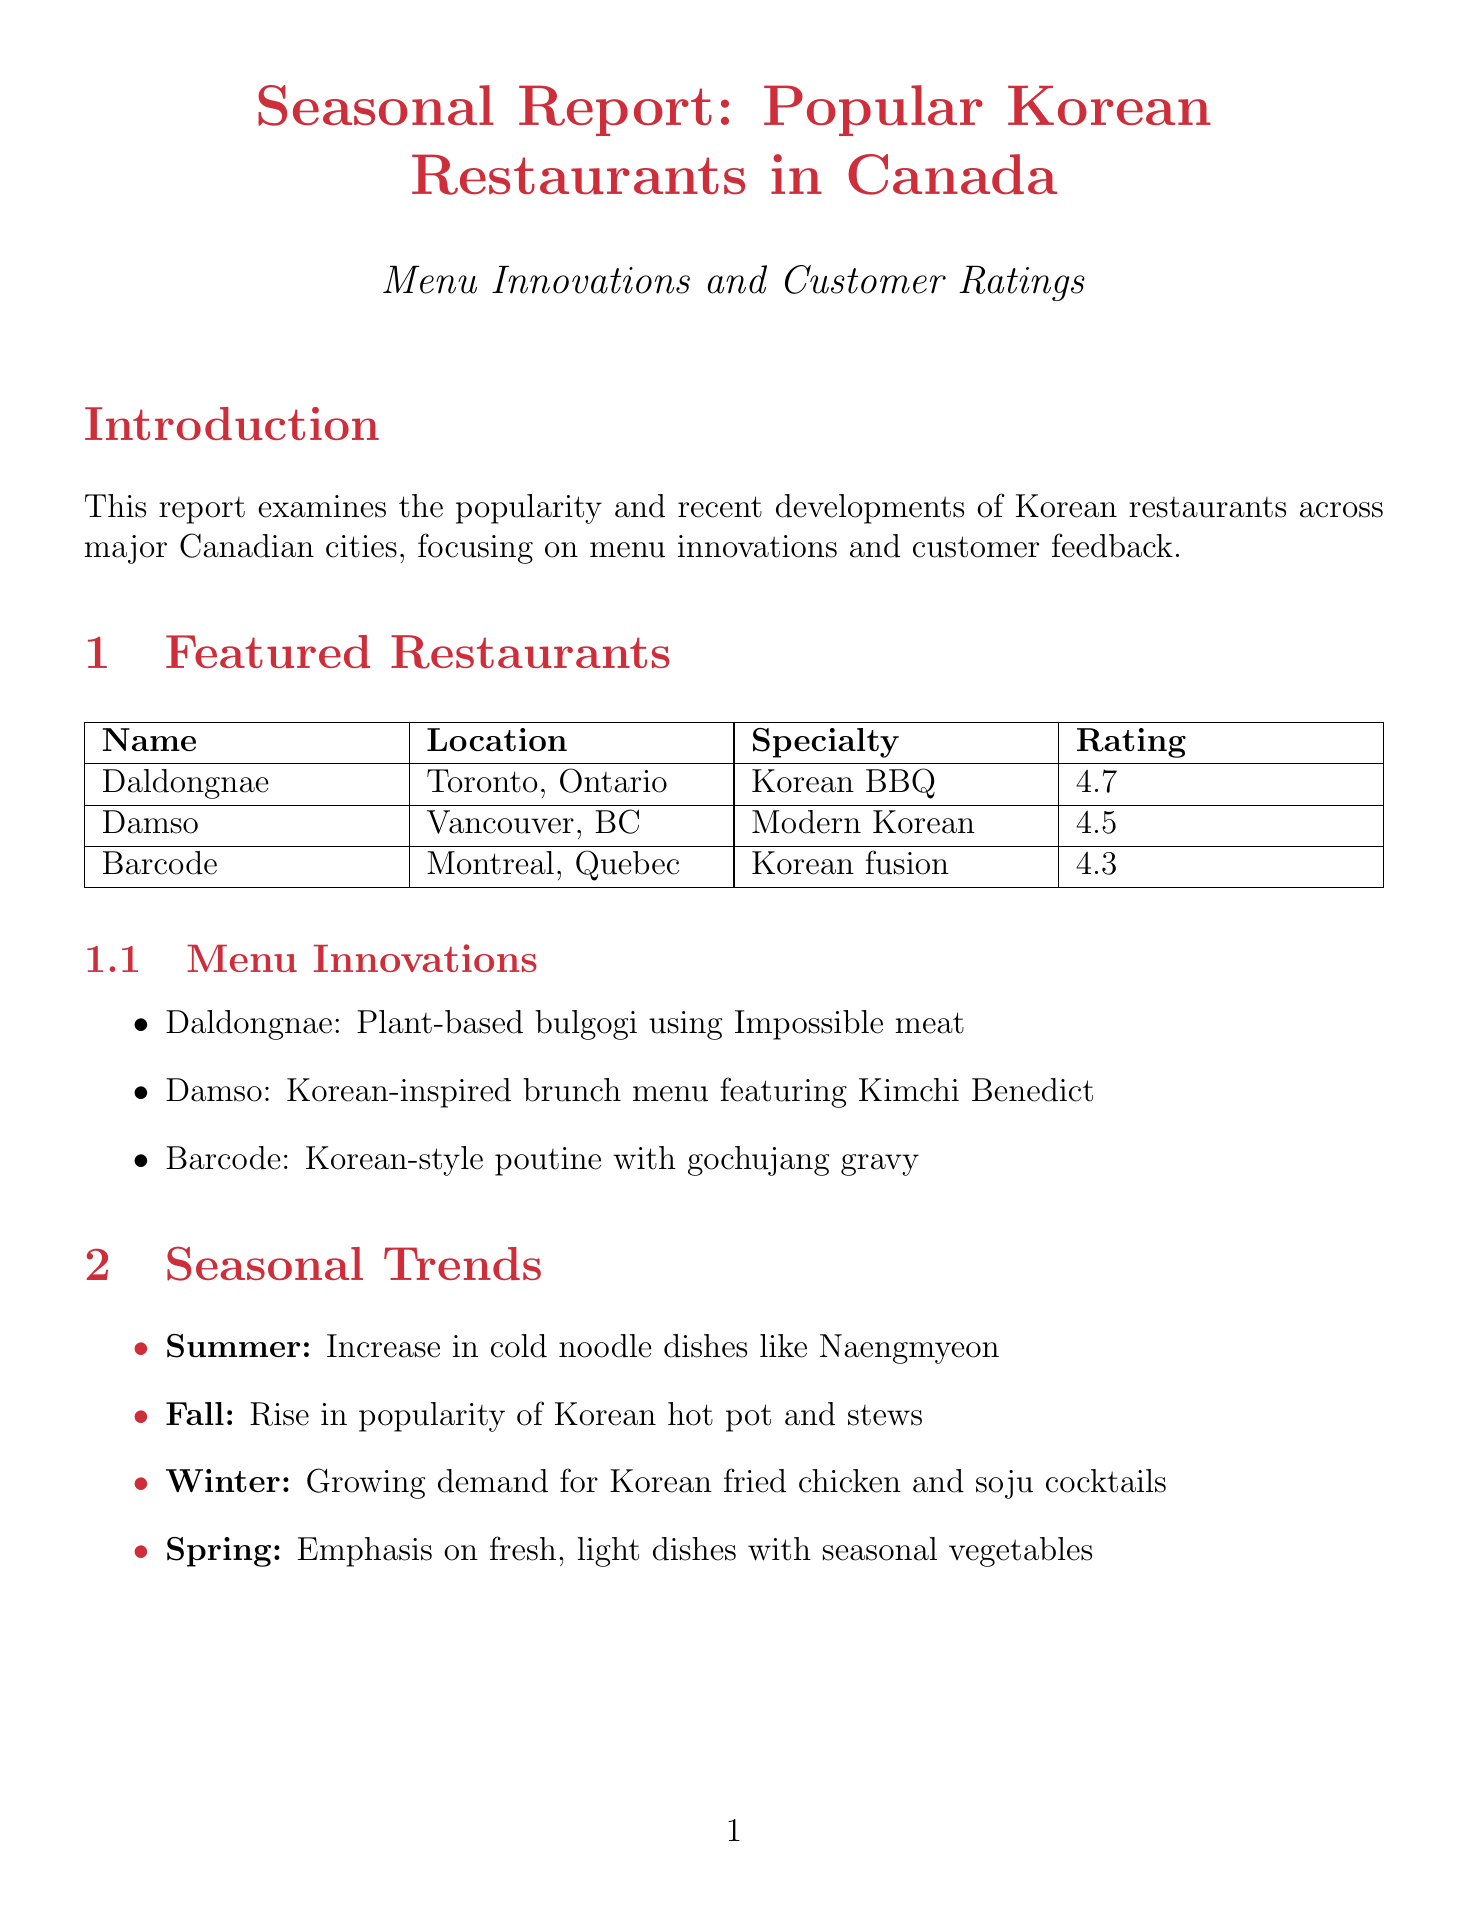What is the title of the report? The title of the report is clearly mentioned at the beginning as "Seasonal Report: Popular Korean Restaurants in Canada - Menu Innovations and Customer Ratings."
Answer: Seasonal Report: Popular Korean Restaurants in Canada - Menu Innovations and Customer Ratings What is the customer rating of Daldongnae? The customer rating of Daldongnae is specified as 4.7.
Answer: 4.7 Which dish is popular at Damso? The report states that the popular dish at Damso is "Kimchi Fried Rice."
Answer: Kimchi Fried Rice What seasonal trend is noted for summer? The seasonal trend for summer is that there is an increase in cold noodle dishes like Naengmyeon.
Answer: Increase in cold noodle dishes like Naengmyeon What is the emphasis on in the spring seasonal trend? The spring seasonal trend emphasizes fresh, light dishes incorporating seasonal vegetables.
Answer: Fresh, light dishes incorporating seasonal vegetables Which region is noted for emphasizing seafood dishes? The report highlights that the West Coast places greater emphasis on seafood dishes and vegetarian options.
Answer: West Coast What is one of the emerging trends mentioned in the report? The report lists "Korean dessert cafes gaining popularity" as one of the emerging trends.
Answer: Korean dessert cafes gaining popularity What type of dining experience do customers prefer? The document states that customers have a preference for casual, authentic atmospheres with modern touches.
Answer: Casual, authentic atmospheres with modern touches 